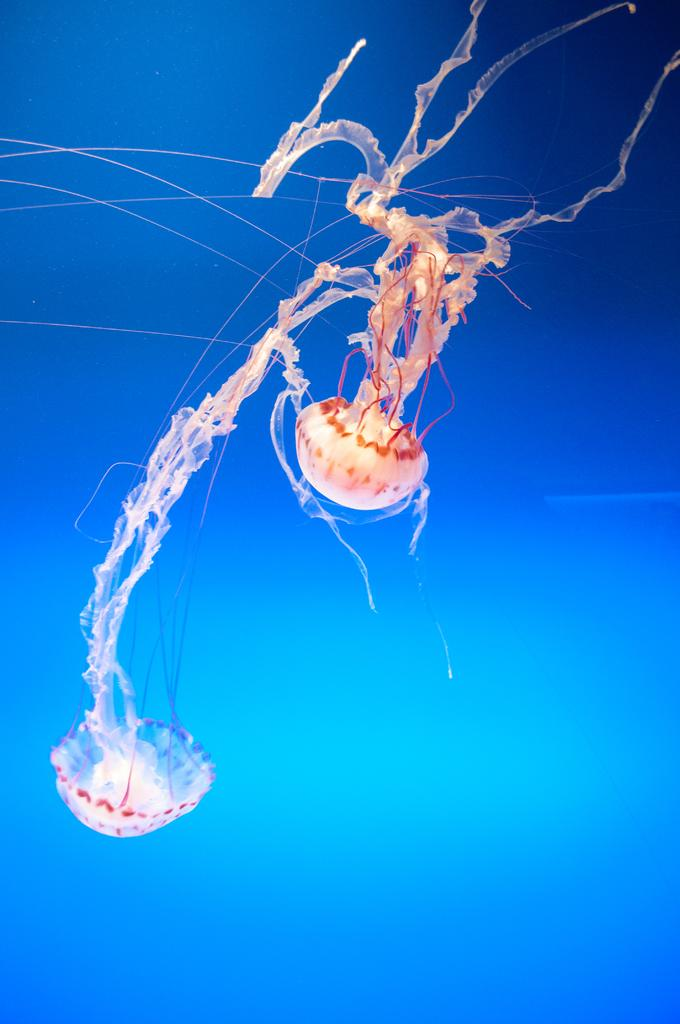What color is the background of the image? The background of the image is blue. What type of sea creature can be seen in the image? There is a jellyfish in the image. What type of wine is being served in the image? There is no wine present in the image; it features a jellyfish in a blue background. Can you tell me how many men are visible in the image? There are no men visible in the image; it features a jellyfish in a blue background. 